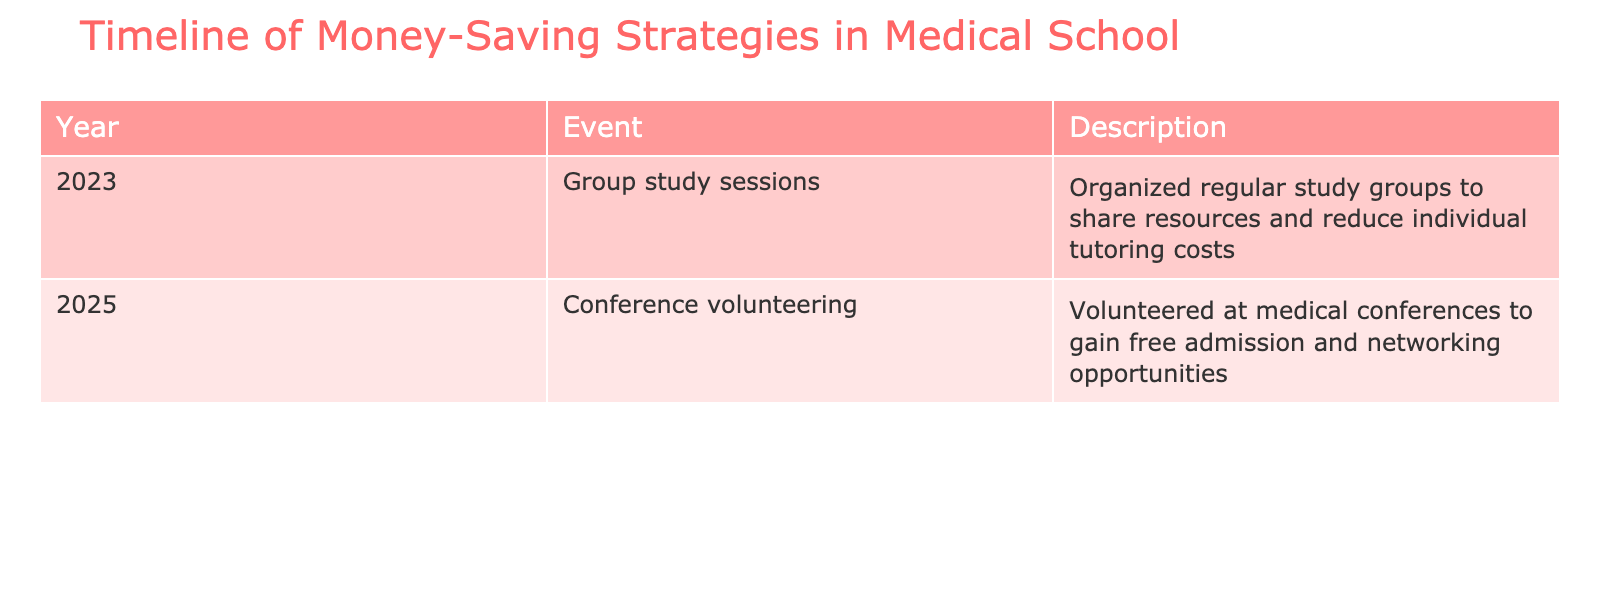What money-saving strategy was implemented in 2023? The table shows that in 2023, the event "Group study sessions" was organized to share resources and reduce individual tutoring costs.
Answer: Group study sessions What is the description of the money-saving strategy for the year 2025? According to the table, in 2025, the description for "Conference volunteering" indicates that individuals volunteered at medical conferences to gain free admission and networking opportunities.
Answer: Volunteered at medical conferences to gain free admission and networking opportunities How many events are listed for the year 2023? The table lists one event for 2023, which is "Group study sessions." Therefore, the count is simply one.
Answer: 1 Is there a strategy that involves volunteering, and if so, which year is it from? Yes, there is a strategy involving volunteering, which is "Conference volunteering," and it is from the year 2025 as noted in the table.
Answer: Yes, from 2025 What is the difference in years between the two strategies implemented? The two strategies are from 2023 and 2025, which gives a difference of 2025 - 2023 = 2 years.
Answer: 2 years In what ways do the descriptions for both years aim to save money? The 2023 strategy focuses on collaboration through group study sessions to reduce individual costs, while the 2025 strategy allows for volunteering to gain free admission, avoiding conference fees. Therefore, both strategies aim to reduce financial burden by sharing resources and providing opportunities for free participation.
Answer: Collaboration and volunteering Was there a money-saving strategy that took place in 2024? The table does not list any events for the year 2024, thus implying there were no strategies implemented that year.
Answer: No Which strategy appears to provide networking opportunities, and when was it implemented? The "Conference volunteering" strategy provides networking opportunities, and it was implemented in the year 2025 according to the table.
Answer: Conference volunteering, 2025 